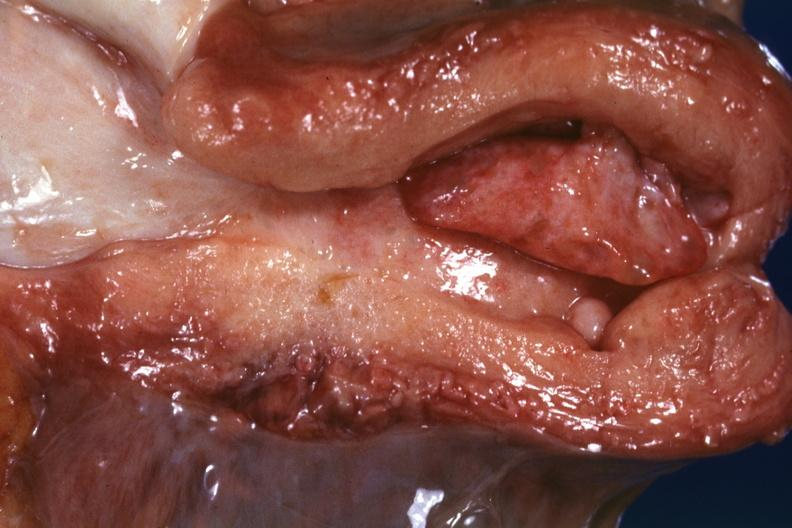s heel ulcer present?
Answer the question using a single word or phrase. No 